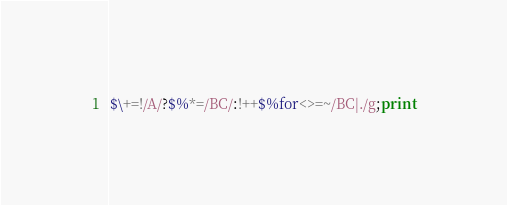Convert code to text. <code><loc_0><loc_0><loc_500><loc_500><_Perl_>$\+=!/A/?$%*=/BC/:!++$%for<>=~/BC|./g;print</code> 